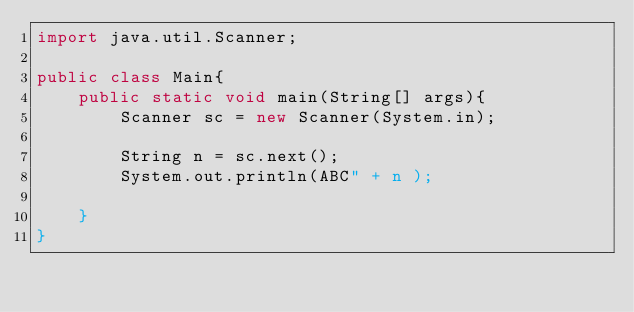Convert code to text. <code><loc_0><loc_0><loc_500><loc_500><_Java_>import java.util.Scanner;

public class Main{
    public static void main(String[] args){
        Scanner sc = new Scanner(System.in);
        
        String n = sc.next();
        System.out.println(ABC" + n );
        
    }
}
</code> 